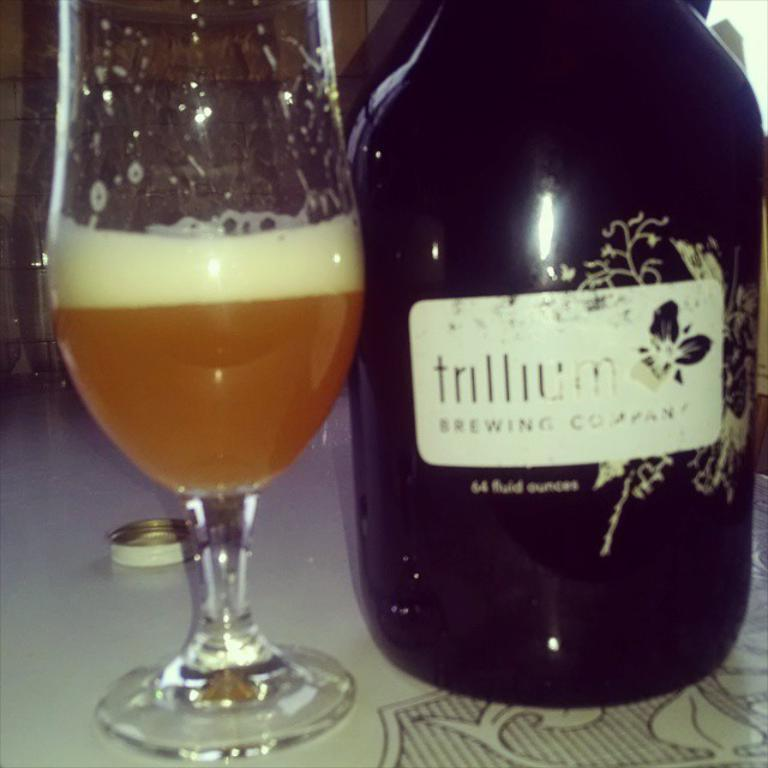Provide a one-sentence caption for the provided image. A bottle of alcohol is adorned with its brewing company product label. 